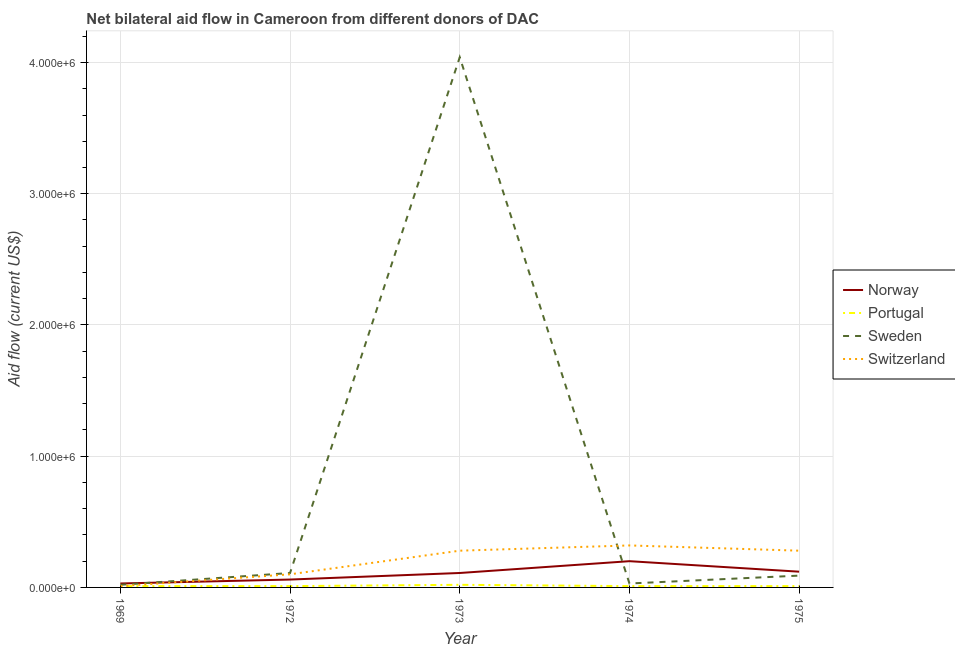How many different coloured lines are there?
Your response must be concise. 4. Does the line corresponding to amount of aid given by sweden intersect with the line corresponding to amount of aid given by portugal?
Your answer should be very brief. No. Is the number of lines equal to the number of legend labels?
Provide a short and direct response. Yes. What is the amount of aid given by switzerland in 1969?
Your response must be concise. 10000. Across all years, what is the maximum amount of aid given by sweden?
Your answer should be very brief. 4.04e+06. Across all years, what is the minimum amount of aid given by norway?
Your answer should be very brief. 3.00e+04. In which year was the amount of aid given by switzerland maximum?
Keep it short and to the point. 1974. In which year was the amount of aid given by sweden minimum?
Your response must be concise. 1969. What is the total amount of aid given by norway in the graph?
Keep it short and to the point. 5.20e+05. What is the difference between the amount of aid given by sweden in 1974 and that in 1975?
Your answer should be compact. -6.00e+04. What is the difference between the amount of aid given by portugal in 1975 and the amount of aid given by switzerland in 1973?
Offer a very short reply. -2.70e+05. What is the average amount of aid given by sweden per year?
Offer a terse response. 8.58e+05. In the year 1973, what is the difference between the amount of aid given by sweden and amount of aid given by norway?
Your answer should be very brief. 3.93e+06. In how many years, is the amount of aid given by norway greater than 1000000 US$?
Offer a very short reply. 0. What is the ratio of the amount of aid given by switzerland in 1972 to that in 1975?
Give a very brief answer. 0.36. Is the amount of aid given by sweden in 1972 less than that in 1975?
Your response must be concise. No. What is the difference between the highest and the lowest amount of aid given by portugal?
Your answer should be compact. 10000. Is the sum of the amount of aid given by switzerland in 1973 and 1975 greater than the maximum amount of aid given by portugal across all years?
Your response must be concise. Yes. Is it the case that in every year, the sum of the amount of aid given by norway and amount of aid given by portugal is greater than the amount of aid given by sweden?
Your response must be concise. No. Does the amount of aid given by portugal monotonically increase over the years?
Your answer should be compact. No. Is the amount of aid given by portugal strictly less than the amount of aid given by switzerland over the years?
Your answer should be very brief. No. Does the graph contain any zero values?
Ensure brevity in your answer.  No. Does the graph contain grids?
Offer a terse response. Yes. How many legend labels are there?
Provide a short and direct response. 4. How are the legend labels stacked?
Provide a succinct answer. Vertical. What is the title of the graph?
Give a very brief answer. Net bilateral aid flow in Cameroon from different donors of DAC. What is the label or title of the X-axis?
Provide a succinct answer. Year. What is the label or title of the Y-axis?
Your response must be concise. Aid flow (current US$). What is the Aid flow (current US$) of Norway in 1969?
Give a very brief answer. 3.00e+04. What is the Aid flow (current US$) of Sweden in 1969?
Make the answer very short. 2.00e+04. What is the Aid flow (current US$) in Norway in 1972?
Your answer should be compact. 6.00e+04. What is the Aid flow (current US$) in Portugal in 1972?
Ensure brevity in your answer.  10000. What is the Aid flow (current US$) in Norway in 1973?
Provide a short and direct response. 1.10e+05. What is the Aid flow (current US$) of Portugal in 1973?
Offer a very short reply. 2.00e+04. What is the Aid flow (current US$) in Sweden in 1973?
Your answer should be compact. 4.04e+06. What is the Aid flow (current US$) in Norway in 1974?
Your response must be concise. 2.00e+05. What is the Aid flow (current US$) of Sweden in 1974?
Give a very brief answer. 3.00e+04. What is the Aid flow (current US$) of Switzerland in 1974?
Offer a terse response. 3.20e+05. What is the Aid flow (current US$) in Norway in 1975?
Make the answer very short. 1.20e+05. What is the Aid flow (current US$) in Sweden in 1975?
Offer a very short reply. 9.00e+04. What is the Aid flow (current US$) in Switzerland in 1975?
Provide a short and direct response. 2.80e+05. Across all years, what is the maximum Aid flow (current US$) in Norway?
Provide a short and direct response. 2.00e+05. Across all years, what is the maximum Aid flow (current US$) in Sweden?
Offer a very short reply. 4.04e+06. Across all years, what is the minimum Aid flow (current US$) in Norway?
Offer a terse response. 3.00e+04. Across all years, what is the minimum Aid flow (current US$) in Portugal?
Your answer should be compact. 10000. What is the total Aid flow (current US$) of Norway in the graph?
Make the answer very short. 5.20e+05. What is the total Aid flow (current US$) of Portugal in the graph?
Provide a short and direct response. 6.00e+04. What is the total Aid flow (current US$) in Sweden in the graph?
Keep it short and to the point. 4.29e+06. What is the total Aid flow (current US$) of Switzerland in the graph?
Ensure brevity in your answer.  9.90e+05. What is the difference between the Aid flow (current US$) in Norway in 1969 and that in 1972?
Offer a very short reply. -3.00e+04. What is the difference between the Aid flow (current US$) in Portugal in 1969 and that in 1972?
Offer a very short reply. 0. What is the difference between the Aid flow (current US$) of Norway in 1969 and that in 1973?
Provide a short and direct response. -8.00e+04. What is the difference between the Aid flow (current US$) of Portugal in 1969 and that in 1973?
Keep it short and to the point. -10000. What is the difference between the Aid flow (current US$) of Sweden in 1969 and that in 1973?
Make the answer very short. -4.02e+06. What is the difference between the Aid flow (current US$) in Switzerland in 1969 and that in 1974?
Keep it short and to the point. -3.10e+05. What is the difference between the Aid flow (current US$) in Portugal in 1969 and that in 1975?
Your answer should be very brief. 0. What is the difference between the Aid flow (current US$) in Switzerland in 1969 and that in 1975?
Keep it short and to the point. -2.70e+05. What is the difference between the Aid flow (current US$) in Sweden in 1972 and that in 1973?
Make the answer very short. -3.93e+06. What is the difference between the Aid flow (current US$) in Norway in 1972 and that in 1974?
Offer a terse response. -1.40e+05. What is the difference between the Aid flow (current US$) of Sweden in 1972 and that in 1974?
Ensure brevity in your answer.  8.00e+04. What is the difference between the Aid flow (current US$) in Norway in 1972 and that in 1975?
Your answer should be compact. -6.00e+04. What is the difference between the Aid flow (current US$) of Switzerland in 1972 and that in 1975?
Provide a succinct answer. -1.80e+05. What is the difference between the Aid flow (current US$) in Norway in 1973 and that in 1974?
Make the answer very short. -9.00e+04. What is the difference between the Aid flow (current US$) of Sweden in 1973 and that in 1974?
Give a very brief answer. 4.01e+06. What is the difference between the Aid flow (current US$) in Switzerland in 1973 and that in 1974?
Your answer should be very brief. -4.00e+04. What is the difference between the Aid flow (current US$) in Portugal in 1973 and that in 1975?
Your response must be concise. 10000. What is the difference between the Aid flow (current US$) in Sweden in 1973 and that in 1975?
Ensure brevity in your answer.  3.95e+06. What is the difference between the Aid flow (current US$) of Switzerland in 1973 and that in 1975?
Offer a terse response. 0. What is the difference between the Aid flow (current US$) of Norway in 1974 and that in 1975?
Your answer should be very brief. 8.00e+04. What is the difference between the Aid flow (current US$) in Portugal in 1974 and that in 1975?
Provide a short and direct response. 0. What is the difference between the Aid flow (current US$) of Switzerland in 1974 and that in 1975?
Your response must be concise. 4.00e+04. What is the difference between the Aid flow (current US$) in Norway in 1969 and the Aid flow (current US$) in Switzerland in 1972?
Offer a very short reply. -7.00e+04. What is the difference between the Aid flow (current US$) of Portugal in 1969 and the Aid flow (current US$) of Sweden in 1972?
Your answer should be very brief. -1.00e+05. What is the difference between the Aid flow (current US$) in Portugal in 1969 and the Aid flow (current US$) in Switzerland in 1972?
Make the answer very short. -9.00e+04. What is the difference between the Aid flow (current US$) in Sweden in 1969 and the Aid flow (current US$) in Switzerland in 1972?
Provide a short and direct response. -8.00e+04. What is the difference between the Aid flow (current US$) in Norway in 1969 and the Aid flow (current US$) in Sweden in 1973?
Your answer should be very brief. -4.01e+06. What is the difference between the Aid flow (current US$) of Portugal in 1969 and the Aid flow (current US$) of Sweden in 1973?
Offer a terse response. -4.03e+06. What is the difference between the Aid flow (current US$) of Portugal in 1969 and the Aid flow (current US$) of Switzerland in 1973?
Offer a very short reply. -2.70e+05. What is the difference between the Aid flow (current US$) in Sweden in 1969 and the Aid flow (current US$) in Switzerland in 1973?
Make the answer very short. -2.60e+05. What is the difference between the Aid flow (current US$) of Norway in 1969 and the Aid flow (current US$) of Portugal in 1974?
Your answer should be compact. 2.00e+04. What is the difference between the Aid flow (current US$) of Portugal in 1969 and the Aid flow (current US$) of Sweden in 1974?
Make the answer very short. -2.00e+04. What is the difference between the Aid flow (current US$) of Portugal in 1969 and the Aid flow (current US$) of Switzerland in 1974?
Keep it short and to the point. -3.10e+05. What is the difference between the Aid flow (current US$) in Norway in 1969 and the Aid flow (current US$) in Portugal in 1975?
Provide a short and direct response. 2.00e+04. What is the difference between the Aid flow (current US$) in Norway in 1969 and the Aid flow (current US$) in Switzerland in 1975?
Your response must be concise. -2.50e+05. What is the difference between the Aid flow (current US$) of Norway in 1972 and the Aid flow (current US$) of Portugal in 1973?
Offer a terse response. 4.00e+04. What is the difference between the Aid flow (current US$) of Norway in 1972 and the Aid flow (current US$) of Sweden in 1973?
Your answer should be very brief. -3.98e+06. What is the difference between the Aid flow (current US$) of Norway in 1972 and the Aid flow (current US$) of Switzerland in 1973?
Provide a short and direct response. -2.20e+05. What is the difference between the Aid flow (current US$) in Portugal in 1972 and the Aid flow (current US$) in Sweden in 1973?
Keep it short and to the point. -4.03e+06. What is the difference between the Aid flow (current US$) in Norway in 1972 and the Aid flow (current US$) in Portugal in 1974?
Offer a terse response. 5.00e+04. What is the difference between the Aid flow (current US$) of Norway in 1972 and the Aid flow (current US$) of Switzerland in 1974?
Your answer should be very brief. -2.60e+05. What is the difference between the Aid flow (current US$) of Portugal in 1972 and the Aid flow (current US$) of Sweden in 1974?
Your answer should be compact. -2.00e+04. What is the difference between the Aid flow (current US$) of Portugal in 1972 and the Aid flow (current US$) of Switzerland in 1974?
Your response must be concise. -3.10e+05. What is the difference between the Aid flow (current US$) in Sweden in 1972 and the Aid flow (current US$) in Switzerland in 1974?
Ensure brevity in your answer.  -2.10e+05. What is the difference between the Aid flow (current US$) of Portugal in 1972 and the Aid flow (current US$) of Switzerland in 1975?
Make the answer very short. -2.70e+05. What is the difference between the Aid flow (current US$) in Sweden in 1972 and the Aid flow (current US$) in Switzerland in 1975?
Keep it short and to the point. -1.70e+05. What is the difference between the Aid flow (current US$) of Norway in 1973 and the Aid flow (current US$) of Portugal in 1974?
Give a very brief answer. 1.00e+05. What is the difference between the Aid flow (current US$) of Norway in 1973 and the Aid flow (current US$) of Switzerland in 1974?
Your response must be concise. -2.10e+05. What is the difference between the Aid flow (current US$) in Sweden in 1973 and the Aid flow (current US$) in Switzerland in 1974?
Provide a short and direct response. 3.72e+06. What is the difference between the Aid flow (current US$) of Norway in 1973 and the Aid flow (current US$) of Portugal in 1975?
Offer a terse response. 1.00e+05. What is the difference between the Aid flow (current US$) in Norway in 1973 and the Aid flow (current US$) in Sweden in 1975?
Ensure brevity in your answer.  2.00e+04. What is the difference between the Aid flow (current US$) of Portugal in 1973 and the Aid flow (current US$) of Switzerland in 1975?
Your response must be concise. -2.60e+05. What is the difference between the Aid flow (current US$) in Sweden in 1973 and the Aid flow (current US$) in Switzerland in 1975?
Your answer should be very brief. 3.76e+06. What is the difference between the Aid flow (current US$) in Norway in 1974 and the Aid flow (current US$) in Sweden in 1975?
Your answer should be compact. 1.10e+05. What is the difference between the Aid flow (current US$) in Norway in 1974 and the Aid flow (current US$) in Switzerland in 1975?
Provide a short and direct response. -8.00e+04. What is the difference between the Aid flow (current US$) in Portugal in 1974 and the Aid flow (current US$) in Switzerland in 1975?
Your response must be concise. -2.70e+05. What is the difference between the Aid flow (current US$) in Sweden in 1974 and the Aid flow (current US$) in Switzerland in 1975?
Keep it short and to the point. -2.50e+05. What is the average Aid flow (current US$) of Norway per year?
Offer a terse response. 1.04e+05. What is the average Aid flow (current US$) of Portugal per year?
Keep it short and to the point. 1.20e+04. What is the average Aid flow (current US$) in Sweden per year?
Provide a succinct answer. 8.58e+05. What is the average Aid flow (current US$) of Switzerland per year?
Your answer should be compact. 1.98e+05. In the year 1969, what is the difference between the Aid flow (current US$) of Norway and Aid flow (current US$) of Switzerland?
Make the answer very short. 2.00e+04. In the year 1972, what is the difference between the Aid flow (current US$) in Norway and Aid flow (current US$) in Portugal?
Provide a succinct answer. 5.00e+04. In the year 1972, what is the difference between the Aid flow (current US$) in Norway and Aid flow (current US$) in Switzerland?
Offer a terse response. -4.00e+04. In the year 1973, what is the difference between the Aid flow (current US$) of Norway and Aid flow (current US$) of Sweden?
Offer a very short reply. -3.93e+06. In the year 1973, what is the difference between the Aid flow (current US$) of Norway and Aid flow (current US$) of Switzerland?
Keep it short and to the point. -1.70e+05. In the year 1973, what is the difference between the Aid flow (current US$) of Portugal and Aid flow (current US$) of Sweden?
Offer a terse response. -4.02e+06. In the year 1973, what is the difference between the Aid flow (current US$) in Portugal and Aid flow (current US$) in Switzerland?
Offer a very short reply. -2.60e+05. In the year 1973, what is the difference between the Aid flow (current US$) of Sweden and Aid flow (current US$) of Switzerland?
Provide a short and direct response. 3.76e+06. In the year 1974, what is the difference between the Aid flow (current US$) of Norway and Aid flow (current US$) of Sweden?
Ensure brevity in your answer.  1.70e+05. In the year 1974, what is the difference between the Aid flow (current US$) of Portugal and Aid flow (current US$) of Switzerland?
Ensure brevity in your answer.  -3.10e+05. In the year 1975, what is the difference between the Aid flow (current US$) of Norway and Aid flow (current US$) of Portugal?
Give a very brief answer. 1.10e+05. In the year 1975, what is the difference between the Aid flow (current US$) in Norway and Aid flow (current US$) in Sweden?
Make the answer very short. 3.00e+04. In the year 1975, what is the difference between the Aid flow (current US$) in Norway and Aid flow (current US$) in Switzerland?
Ensure brevity in your answer.  -1.60e+05. In the year 1975, what is the difference between the Aid flow (current US$) of Portugal and Aid flow (current US$) of Sweden?
Provide a succinct answer. -8.00e+04. In the year 1975, what is the difference between the Aid flow (current US$) of Sweden and Aid flow (current US$) of Switzerland?
Your answer should be very brief. -1.90e+05. What is the ratio of the Aid flow (current US$) in Norway in 1969 to that in 1972?
Ensure brevity in your answer.  0.5. What is the ratio of the Aid flow (current US$) of Sweden in 1969 to that in 1972?
Make the answer very short. 0.18. What is the ratio of the Aid flow (current US$) of Norway in 1969 to that in 1973?
Offer a very short reply. 0.27. What is the ratio of the Aid flow (current US$) of Portugal in 1969 to that in 1973?
Your answer should be very brief. 0.5. What is the ratio of the Aid flow (current US$) of Sweden in 1969 to that in 1973?
Provide a short and direct response. 0.01. What is the ratio of the Aid flow (current US$) in Switzerland in 1969 to that in 1973?
Your answer should be compact. 0.04. What is the ratio of the Aid flow (current US$) in Norway in 1969 to that in 1974?
Give a very brief answer. 0.15. What is the ratio of the Aid flow (current US$) in Switzerland in 1969 to that in 1974?
Your answer should be compact. 0.03. What is the ratio of the Aid flow (current US$) in Norway in 1969 to that in 1975?
Your answer should be very brief. 0.25. What is the ratio of the Aid flow (current US$) in Portugal in 1969 to that in 1975?
Give a very brief answer. 1. What is the ratio of the Aid flow (current US$) in Sweden in 1969 to that in 1975?
Keep it short and to the point. 0.22. What is the ratio of the Aid flow (current US$) of Switzerland in 1969 to that in 1975?
Your answer should be compact. 0.04. What is the ratio of the Aid flow (current US$) in Norway in 1972 to that in 1973?
Your response must be concise. 0.55. What is the ratio of the Aid flow (current US$) of Portugal in 1972 to that in 1973?
Your response must be concise. 0.5. What is the ratio of the Aid flow (current US$) of Sweden in 1972 to that in 1973?
Offer a very short reply. 0.03. What is the ratio of the Aid flow (current US$) of Switzerland in 1972 to that in 1973?
Offer a very short reply. 0.36. What is the ratio of the Aid flow (current US$) in Sweden in 1972 to that in 1974?
Provide a short and direct response. 3.67. What is the ratio of the Aid flow (current US$) in Switzerland in 1972 to that in 1974?
Ensure brevity in your answer.  0.31. What is the ratio of the Aid flow (current US$) in Norway in 1972 to that in 1975?
Make the answer very short. 0.5. What is the ratio of the Aid flow (current US$) in Sweden in 1972 to that in 1975?
Provide a short and direct response. 1.22. What is the ratio of the Aid flow (current US$) of Switzerland in 1972 to that in 1975?
Make the answer very short. 0.36. What is the ratio of the Aid flow (current US$) in Norway in 1973 to that in 1974?
Offer a very short reply. 0.55. What is the ratio of the Aid flow (current US$) in Sweden in 1973 to that in 1974?
Your answer should be compact. 134.67. What is the ratio of the Aid flow (current US$) of Norway in 1973 to that in 1975?
Make the answer very short. 0.92. What is the ratio of the Aid flow (current US$) of Portugal in 1973 to that in 1975?
Offer a very short reply. 2. What is the ratio of the Aid flow (current US$) in Sweden in 1973 to that in 1975?
Provide a short and direct response. 44.89. What is the ratio of the Aid flow (current US$) of Switzerland in 1973 to that in 1975?
Your response must be concise. 1. What is the ratio of the Aid flow (current US$) of Portugal in 1974 to that in 1975?
Give a very brief answer. 1. What is the ratio of the Aid flow (current US$) in Sweden in 1974 to that in 1975?
Give a very brief answer. 0.33. What is the difference between the highest and the second highest Aid flow (current US$) of Norway?
Your response must be concise. 8.00e+04. What is the difference between the highest and the second highest Aid flow (current US$) of Portugal?
Provide a succinct answer. 10000. What is the difference between the highest and the second highest Aid flow (current US$) of Sweden?
Give a very brief answer. 3.93e+06. What is the difference between the highest and the second highest Aid flow (current US$) in Switzerland?
Keep it short and to the point. 4.00e+04. What is the difference between the highest and the lowest Aid flow (current US$) in Portugal?
Your response must be concise. 10000. What is the difference between the highest and the lowest Aid flow (current US$) in Sweden?
Give a very brief answer. 4.02e+06. What is the difference between the highest and the lowest Aid flow (current US$) in Switzerland?
Provide a short and direct response. 3.10e+05. 